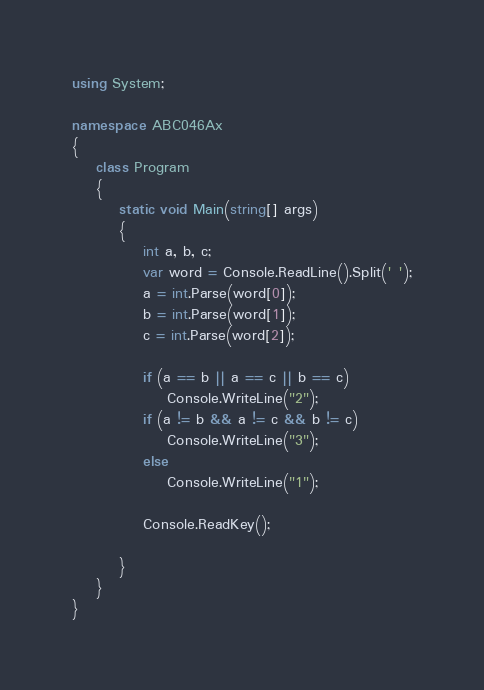Convert code to text. <code><loc_0><loc_0><loc_500><loc_500><_C#_>using System;

namespace ABC046Ax
{
    class Program
    {
        static void Main(string[] args)
        {
            int a, b, c;
            var word = Console.ReadLine().Split(' ');
            a = int.Parse(word[0]);
            b = int.Parse(word[1]);
            c = int.Parse(word[2]);

            if (a == b || a == c || b == c)
                Console.WriteLine("2");
            if (a != b && a != c && b != c)
                Console.WriteLine("3");
            else
                Console.WriteLine("1");

            Console.ReadKey();

        }
    }
}
</code> 